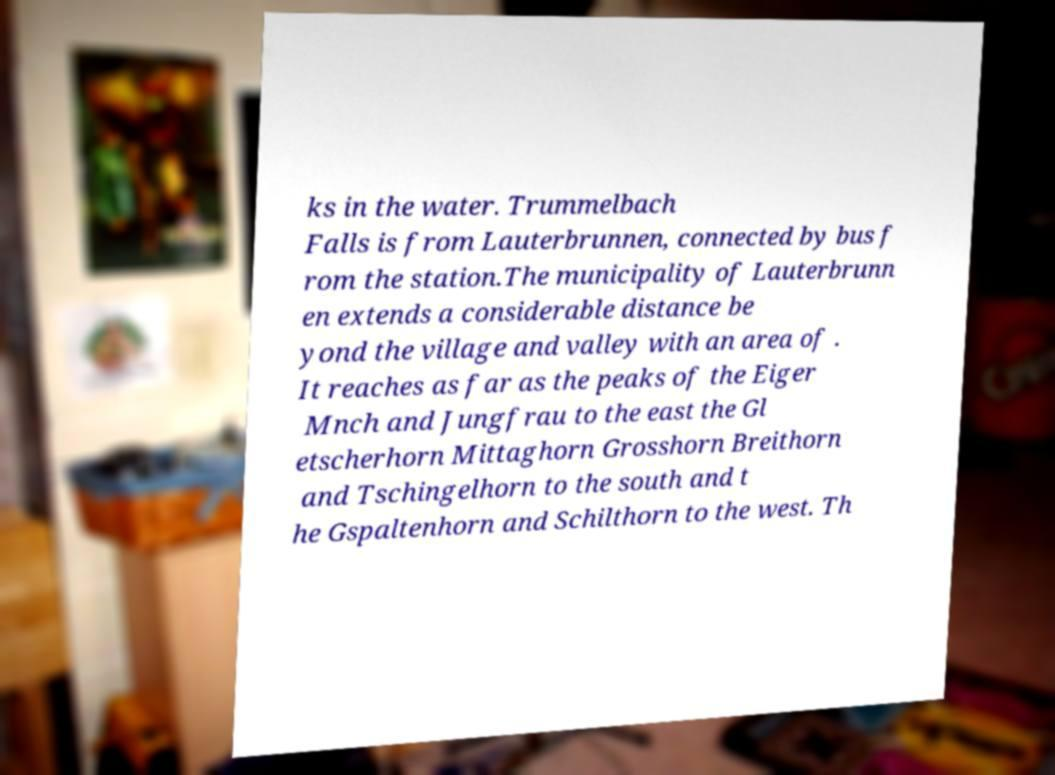What messages or text are displayed in this image? I need them in a readable, typed format. ks in the water. Trummelbach Falls is from Lauterbrunnen, connected by bus f rom the station.The municipality of Lauterbrunn en extends a considerable distance be yond the village and valley with an area of . It reaches as far as the peaks of the Eiger Mnch and Jungfrau to the east the Gl etscherhorn Mittaghorn Grosshorn Breithorn and Tschingelhorn to the south and t he Gspaltenhorn and Schilthorn to the west. Th 